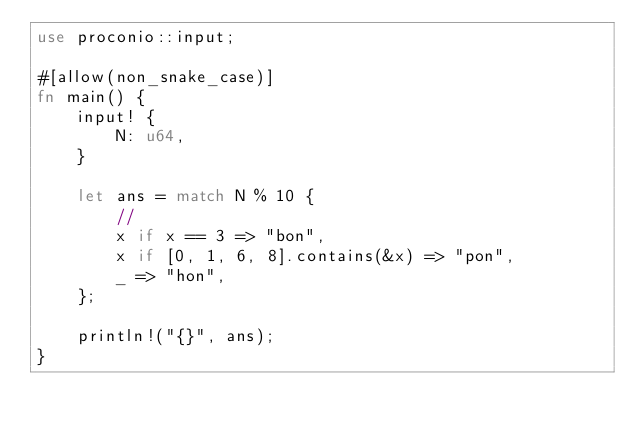<code> <loc_0><loc_0><loc_500><loc_500><_Rust_>use proconio::input;

#[allow(non_snake_case)]
fn main() {
    input! {
        N: u64,
    }

    let ans = match N % 10 {
        //
        x if x == 3 => "bon",
        x if [0, 1, 6, 8].contains(&x) => "pon",
        _ => "hon",
    };

    println!("{}", ans);
}
</code> 